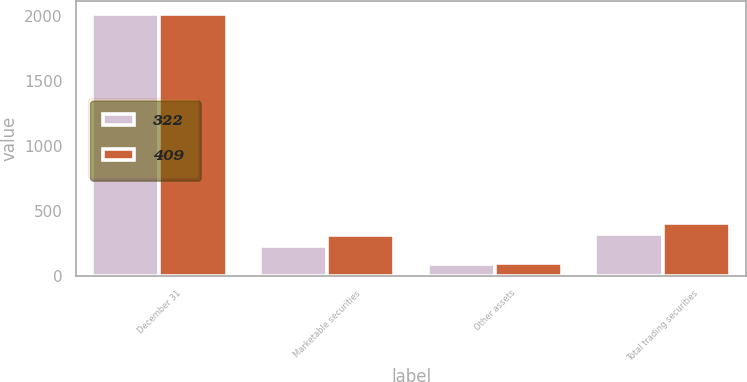<chart> <loc_0><loc_0><loc_500><loc_500><stacked_bar_chart><ecel><fcel>December 31<fcel>Marketable securities<fcel>Other assets<fcel>Total trading securities<nl><fcel>322<fcel>2015<fcel>229<fcel>93<fcel>322<nl><fcel>409<fcel>2014<fcel>315<fcel>94<fcel>409<nl></chart> 